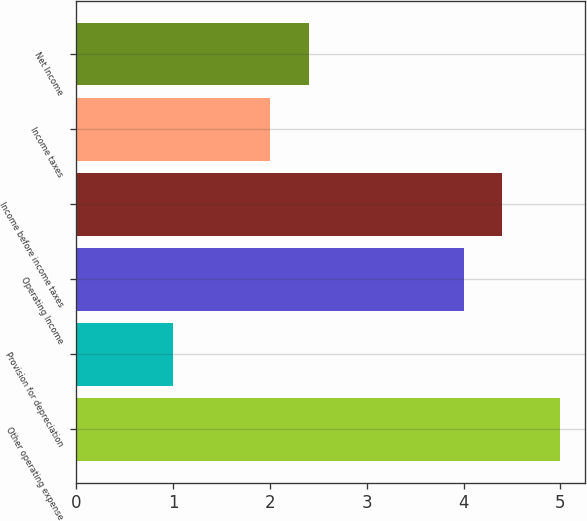Convert chart to OTSL. <chart><loc_0><loc_0><loc_500><loc_500><bar_chart><fcel>Other operating expense<fcel>Provision for depreciation<fcel>Operating Income<fcel>Income before income taxes<fcel>Income taxes<fcel>Net Income<nl><fcel>5<fcel>1<fcel>4<fcel>4.4<fcel>2<fcel>2.4<nl></chart> 